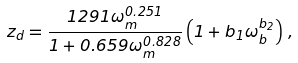<formula> <loc_0><loc_0><loc_500><loc_500>z _ { d } = \frac { 1 2 9 1 \omega _ { m } ^ { 0 . 2 5 1 } } { 1 + 0 . 6 5 9 \omega _ { m } ^ { 0 . 8 2 8 } } \left ( 1 + b _ { 1 } \omega _ { b } ^ { b _ { 2 } } \right ) \, ,</formula> 